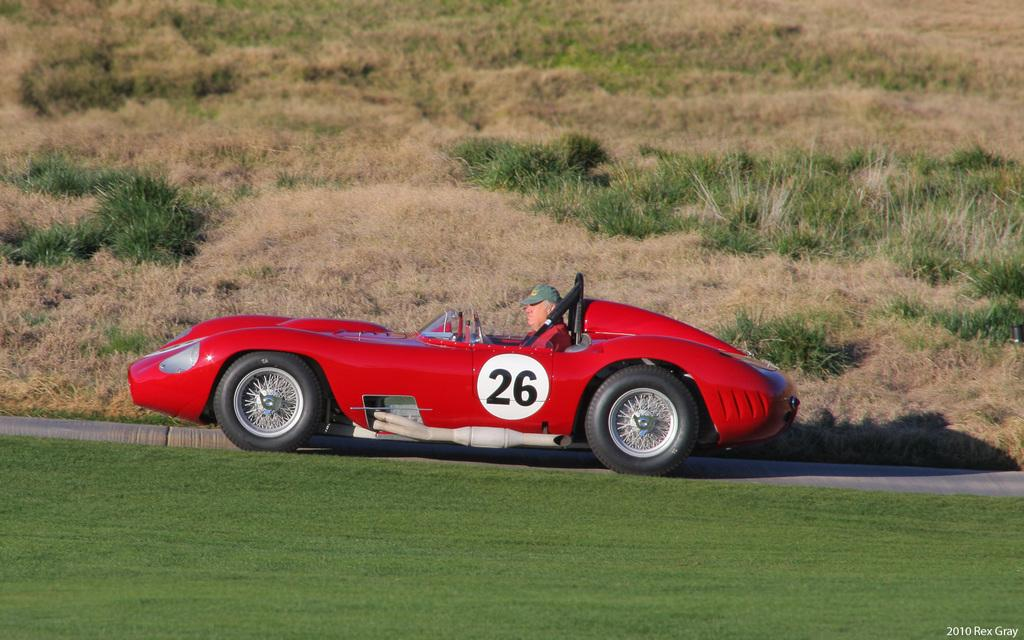What is the person in the image doing? There is a person sitting in a car in the image. What color is the car the person is sitting in? The car is red in color. Where is the car located? The car is on the grass. What can be seen in the background of the image? There are plants in the background of the image. What type of toys can be seen on the car's dashboard in the image? There are no toys visible on the car's dashboard in the image. What is the texture of the car's seats in the image? The texture of the car's seats cannot be determined from the image. 